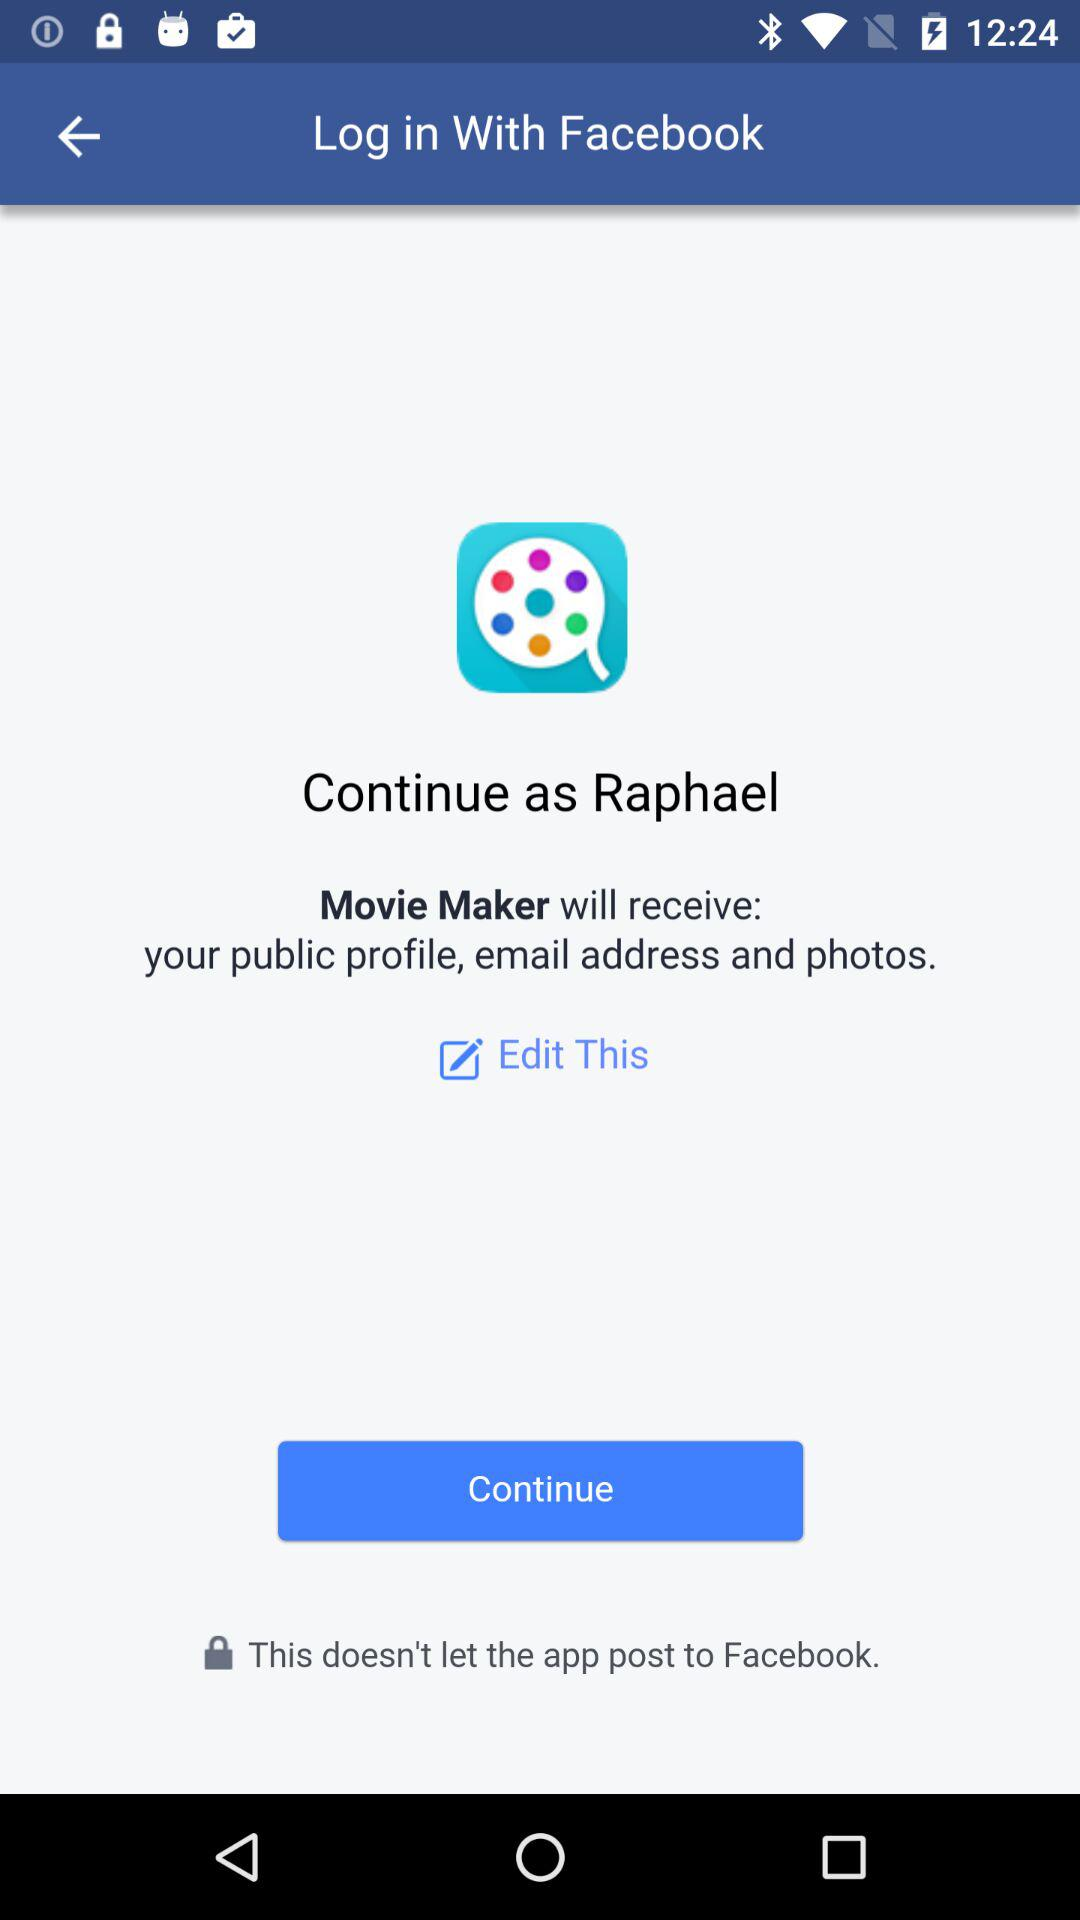What application are we accessing? You are accessing the "Facebook" application. 